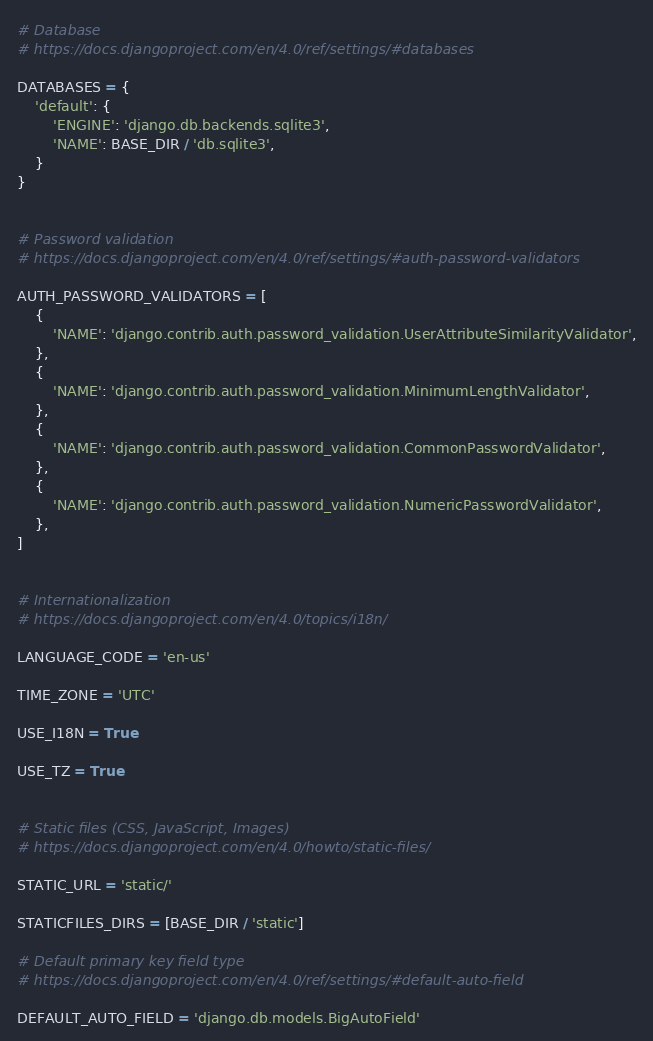<code> <loc_0><loc_0><loc_500><loc_500><_Python_>

# Database
# https://docs.djangoproject.com/en/4.0/ref/settings/#databases

DATABASES = {
    'default': {
        'ENGINE': 'django.db.backends.sqlite3',
        'NAME': BASE_DIR / 'db.sqlite3',
    }
}


# Password validation
# https://docs.djangoproject.com/en/4.0/ref/settings/#auth-password-validators

AUTH_PASSWORD_VALIDATORS = [
    {
        'NAME': 'django.contrib.auth.password_validation.UserAttributeSimilarityValidator',
    },
    {
        'NAME': 'django.contrib.auth.password_validation.MinimumLengthValidator',
    },
    {
        'NAME': 'django.contrib.auth.password_validation.CommonPasswordValidator',
    },
    {
        'NAME': 'django.contrib.auth.password_validation.NumericPasswordValidator',
    },
]


# Internationalization
# https://docs.djangoproject.com/en/4.0/topics/i18n/

LANGUAGE_CODE = 'en-us'

TIME_ZONE = 'UTC'

USE_I18N = True

USE_TZ = True


# Static files (CSS, JavaScript, Images)
# https://docs.djangoproject.com/en/4.0/howto/static-files/

STATIC_URL = 'static/'

STATICFILES_DIRS = [BASE_DIR / 'static']

# Default primary key field type
# https://docs.djangoproject.com/en/4.0/ref/settings/#default-auto-field

DEFAULT_AUTO_FIELD = 'django.db.models.BigAutoField'
</code> 